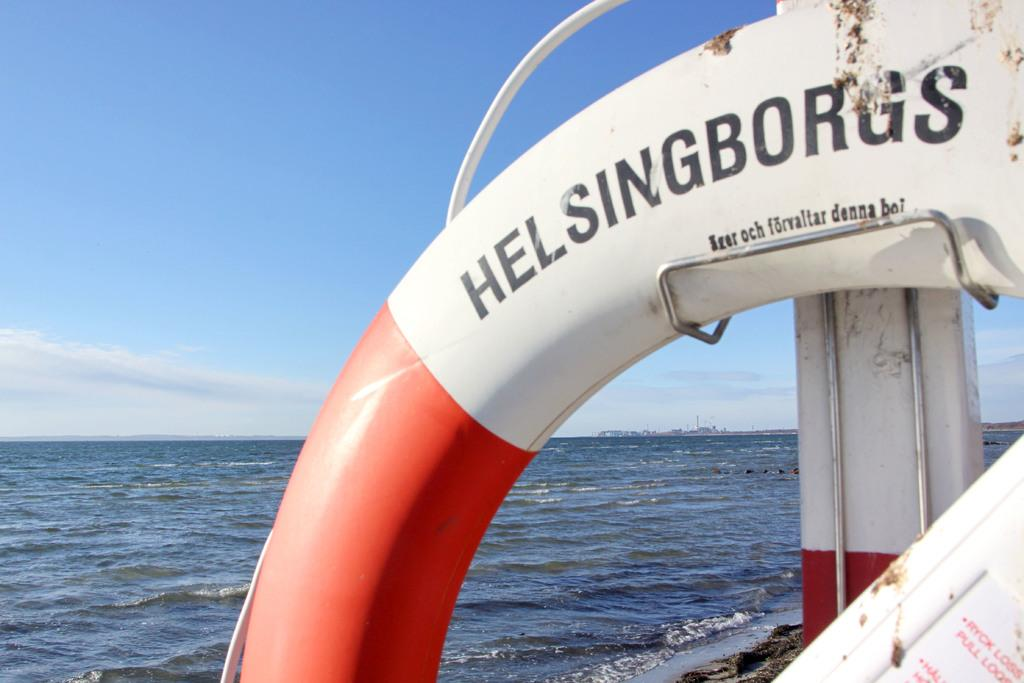<image>
Write a terse but informative summary of the picture. Black Helsingborgs sign on a boat in the water 